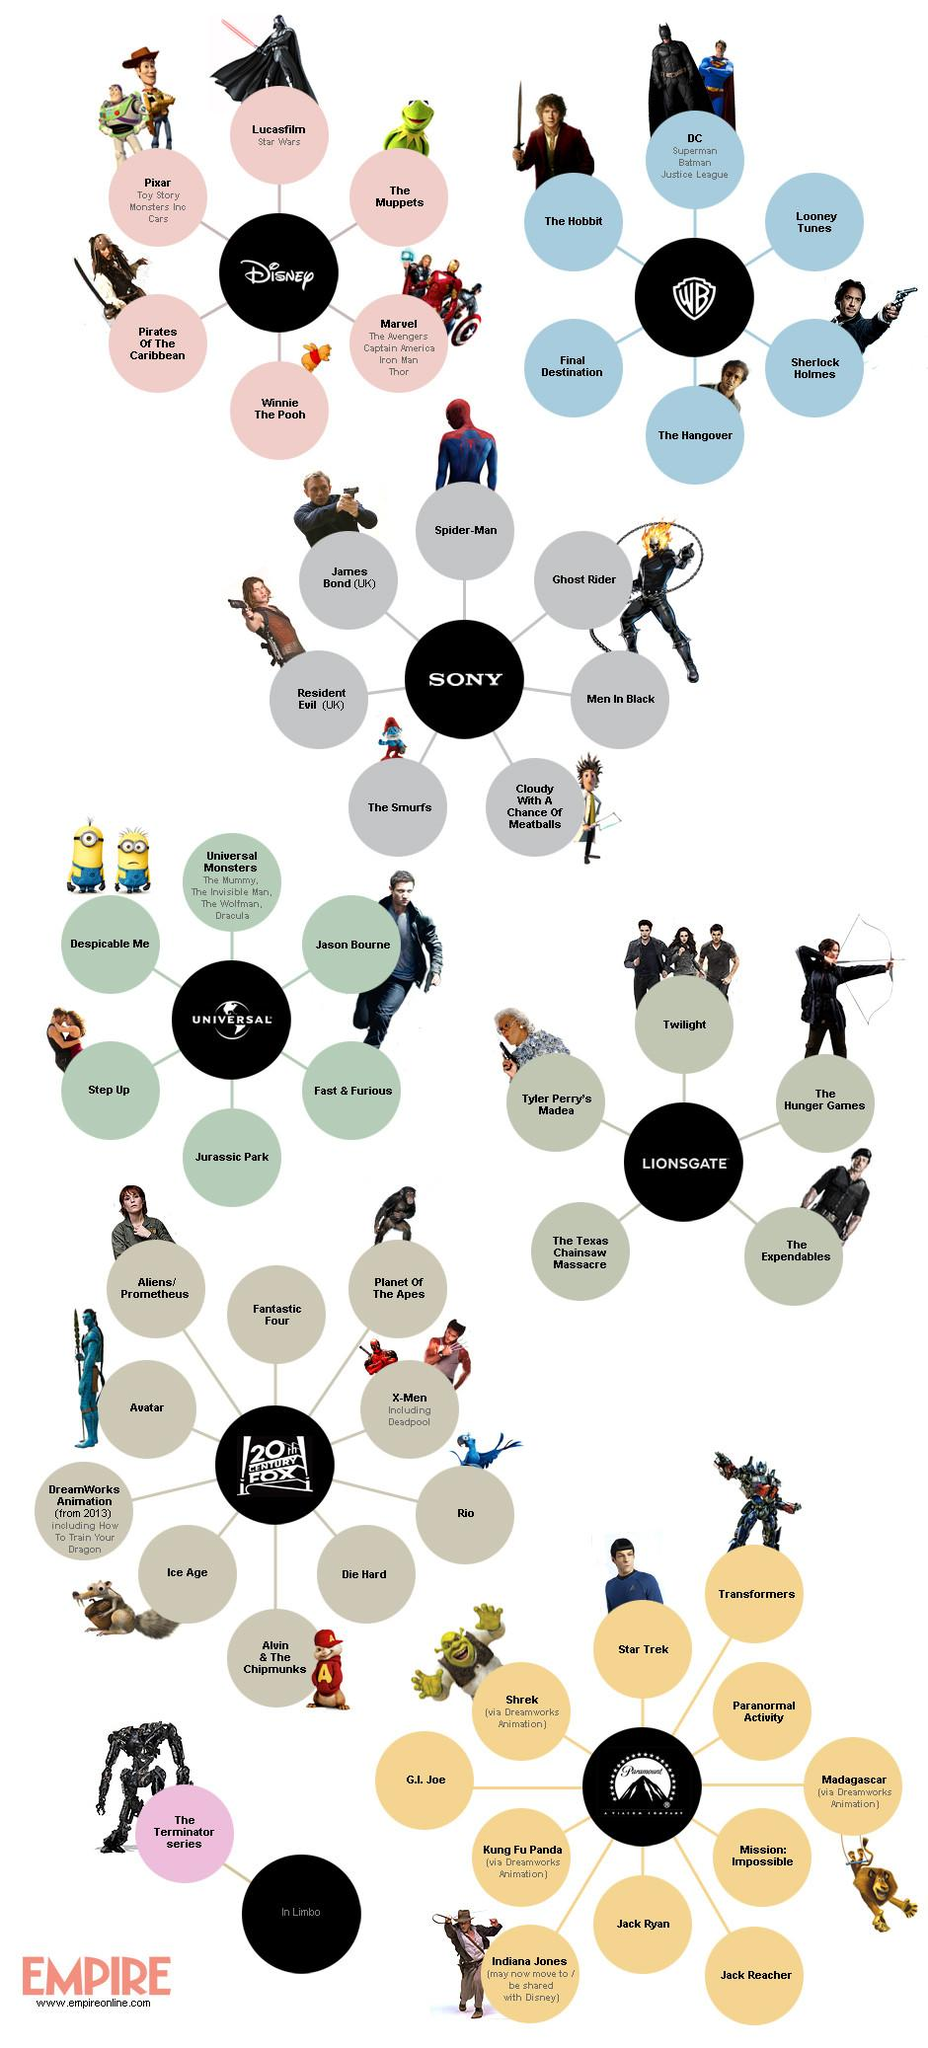Draw attention to some important aspects in this diagram. The production company that has not collaborated with Dreamworks to make animation movies is Universal. It is known that Paramount Pictures, the production company responsible for several popular movies such as Star Trek, Paranormal Activity, and Mission: Impossible, has produced a variety of successful films throughout its history. Warner Bros. is the company that represents the production that is represented by the letters WB, Walter Bros, Wright Bros, or Warner Bros. The titular role of James Bond was played by Daniel Craig. The Sony-produced superhero movie is "Spiderman. 